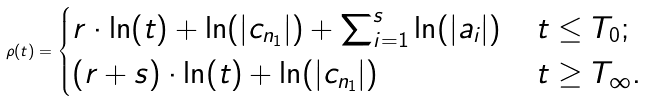Convert formula to latex. <formula><loc_0><loc_0><loc_500><loc_500>\rho ( t ) = \begin{cases} r \cdot \ln ( t ) + \ln ( | c _ { n _ { 1 } } | ) + \sum _ { i = 1 } ^ { s } \ln ( | a _ { i } | ) & \, t \leq T _ { 0 } ; \\ ( r + s ) \cdot \ln ( t ) + \ln ( | c _ { n _ { 1 } } | ) & \, t \geq T _ { \infty } . \end{cases}</formula> 